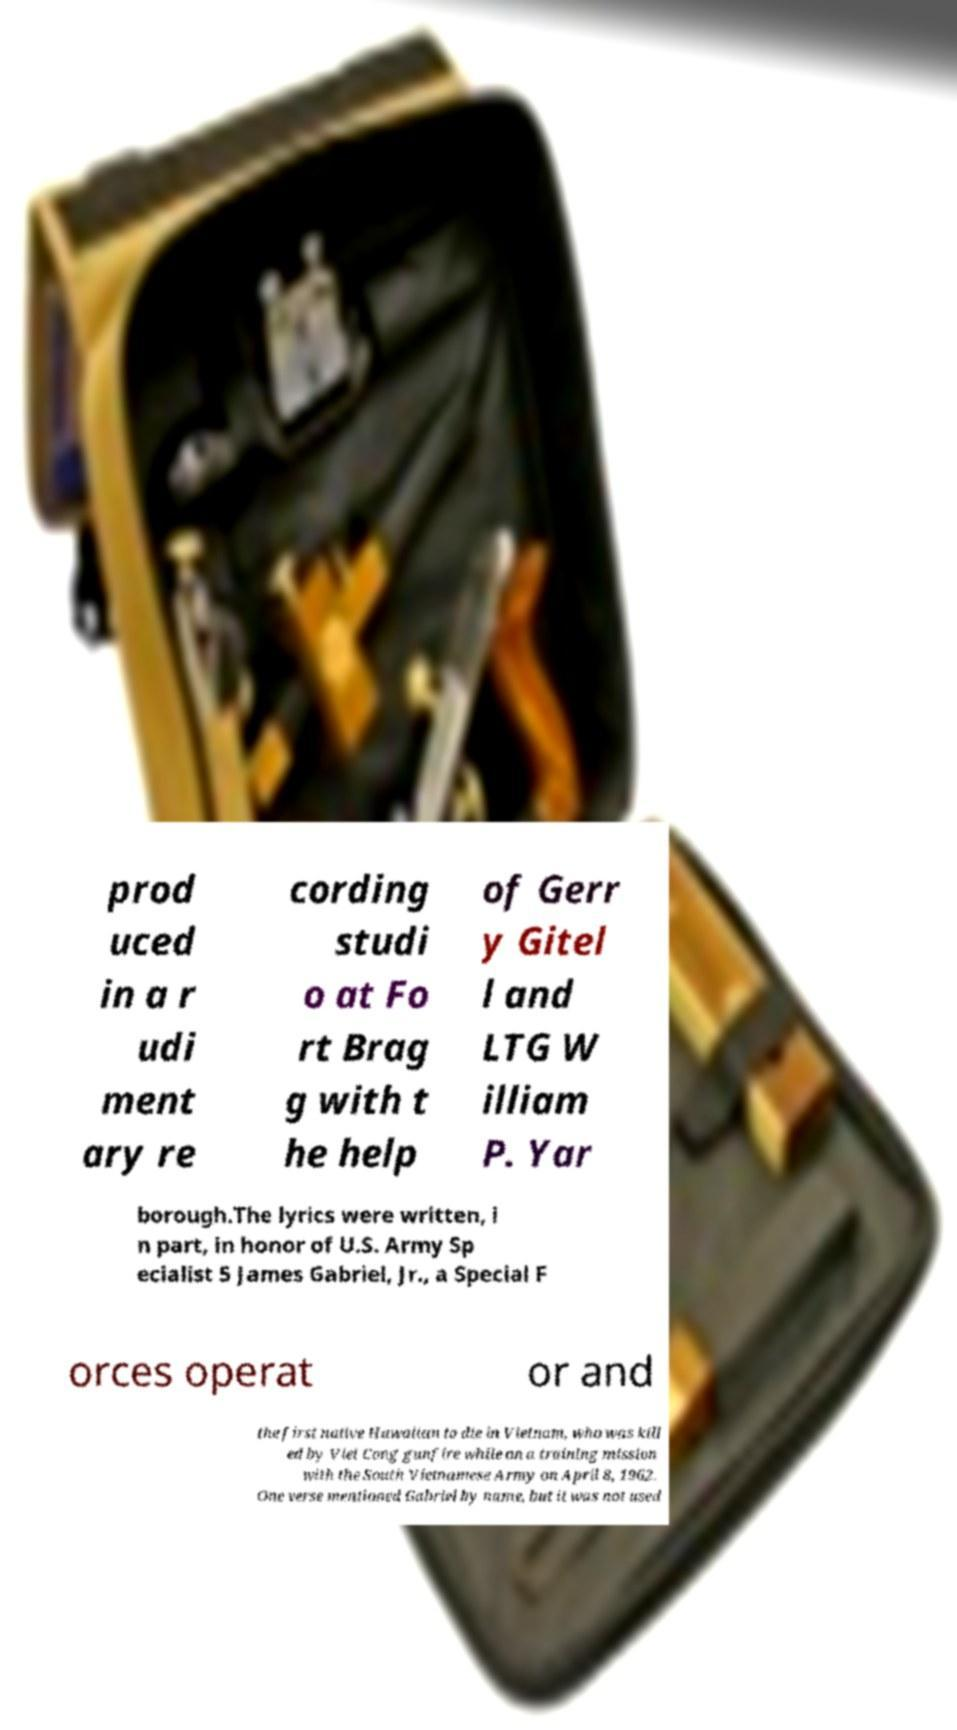I need the written content from this picture converted into text. Can you do that? prod uced in a r udi ment ary re cording studi o at Fo rt Brag g with t he help of Gerr y Gitel l and LTG W illiam P. Yar borough.The lyrics were written, i n part, in honor of U.S. Army Sp ecialist 5 James Gabriel, Jr., a Special F orces operat or and the first native Hawaiian to die in Vietnam, who was kill ed by Viet Cong gunfire while on a training mission with the South Vietnamese Army on April 8, 1962. One verse mentioned Gabriel by name, but it was not used 